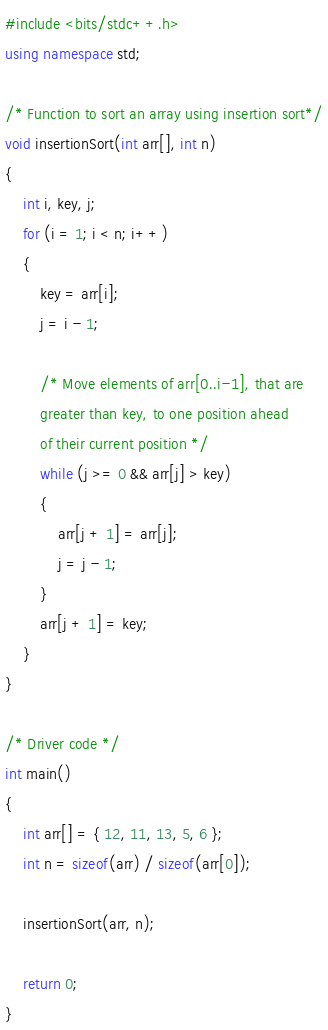<code> <loc_0><loc_0><loc_500><loc_500><_C++_>#include <bits/stdc++.h> 
using namespace std; 
  
/* Function to sort an array using insertion sort*/
void insertionSort(int arr[], int n)  
{  
    int i, key, j;  
    for (i = 1; i < n; i++) 
    {  
        key = arr[i];  
        j = i - 1;  
  
        /* Move elements of arr[0..i-1], that are  
        greater than key, to one position ahead  
        of their current position */
        while (j >= 0 && arr[j] > key) 
        {  
            arr[j + 1] = arr[j];  
            j = j - 1;  
        }  
        arr[j + 1] = key;  
    }  
}  
  
/* Driver code */
int main()  
{  
    int arr[] = { 12, 11, 13, 5, 6 };  
    int n = sizeof(arr) / sizeof(arr[0]);  
  
    insertionSort(arr, n);  
  
    return 0;  
}  
</code> 